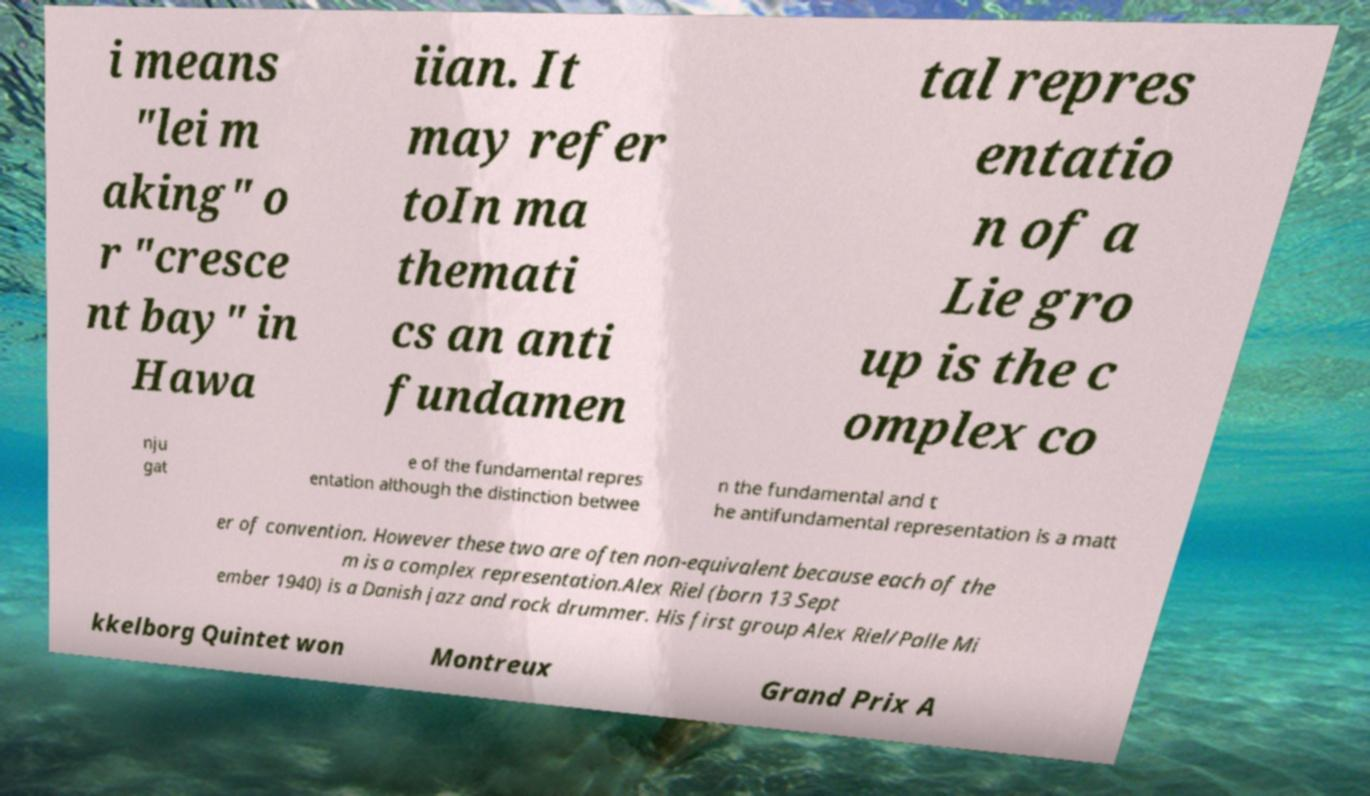I need the written content from this picture converted into text. Can you do that? i means "lei m aking" o r "cresce nt bay" in Hawa iian. It may refer toIn ma themati cs an anti fundamen tal repres entatio n of a Lie gro up is the c omplex co nju gat e of the fundamental repres entation although the distinction betwee n the fundamental and t he antifundamental representation is a matt er of convention. However these two are often non-equivalent because each of the m is a complex representation.Alex Riel (born 13 Sept ember 1940) is a Danish jazz and rock drummer. His first group Alex Riel/Palle Mi kkelborg Quintet won Montreux Grand Prix A 